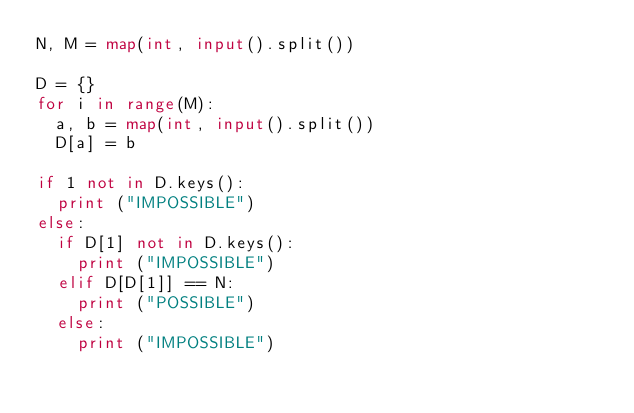Convert code to text. <code><loc_0><loc_0><loc_500><loc_500><_Python_>N, M = map(int, input().split())

D = {}
for i in range(M):
  a, b = map(int, input().split())
  D[a] = b

if 1 not in D.keys():
  print ("IMPOSSIBLE")
else:
  if D[1] not in D.keys():
    print ("IMPOSSIBLE")
  elif D[D[1]] == N:
    print ("POSSIBLE")
  else:
    print ("IMPOSSIBLE")
</code> 